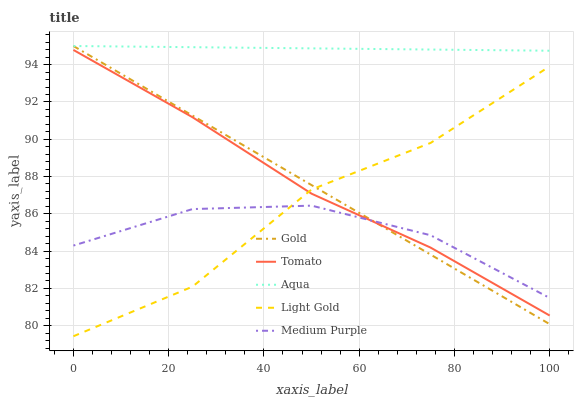Does Medium Purple have the minimum area under the curve?
Answer yes or no. Yes. Does Aqua have the maximum area under the curve?
Answer yes or no. Yes. Does Light Gold have the minimum area under the curve?
Answer yes or no. No. Does Light Gold have the maximum area under the curve?
Answer yes or no. No. Is Aqua the smoothest?
Answer yes or no. Yes. Is Light Gold the roughest?
Answer yes or no. Yes. Is Medium Purple the smoothest?
Answer yes or no. No. Is Medium Purple the roughest?
Answer yes or no. No. Does Light Gold have the lowest value?
Answer yes or no. Yes. Does Medium Purple have the lowest value?
Answer yes or no. No. Does Gold have the highest value?
Answer yes or no. Yes. Does Light Gold have the highest value?
Answer yes or no. No. Is Light Gold less than Aqua?
Answer yes or no. Yes. Is Aqua greater than Light Gold?
Answer yes or no. Yes. Does Aqua intersect Gold?
Answer yes or no. Yes. Is Aqua less than Gold?
Answer yes or no. No. Is Aqua greater than Gold?
Answer yes or no. No. Does Light Gold intersect Aqua?
Answer yes or no. No. 